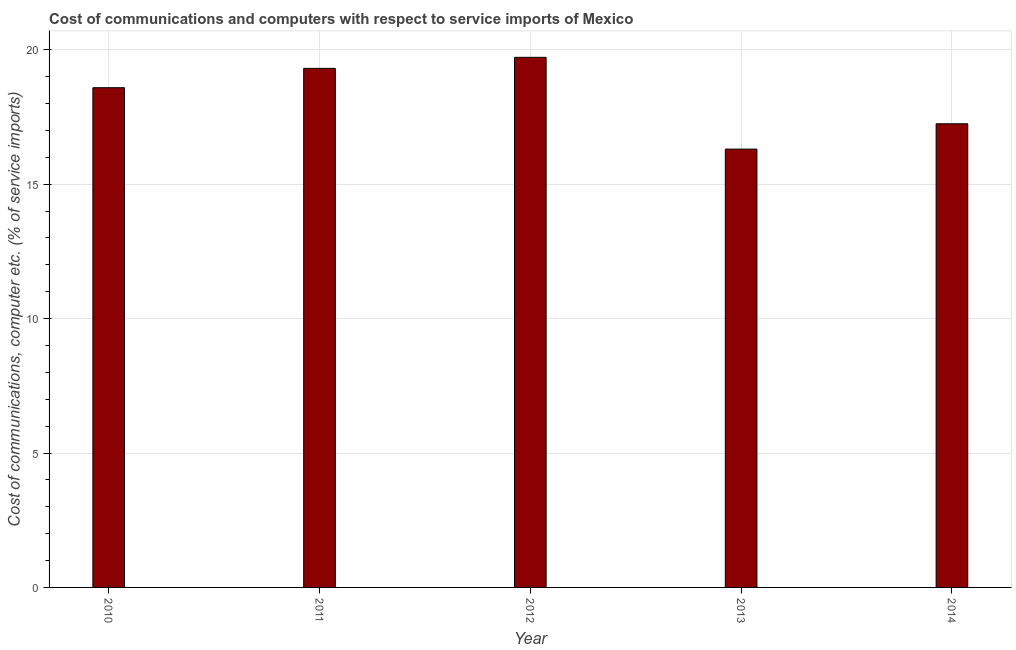Does the graph contain any zero values?
Make the answer very short. No. What is the title of the graph?
Your answer should be compact. Cost of communications and computers with respect to service imports of Mexico. What is the label or title of the Y-axis?
Offer a very short reply. Cost of communications, computer etc. (% of service imports). What is the cost of communications and computer in 2010?
Your answer should be compact. 18.59. Across all years, what is the maximum cost of communications and computer?
Offer a terse response. 19.72. Across all years, what is the minimum cost of communications and computer?
Offer a very short reply. 16.31. In which year was the cost of communications and computer maximum?
Your response must be concise. 2012. In which year was the cost of communications and computer minimum?
Provide a succinct answer. 2013. What is the sum of the cost of communications and computer?
Offer a very short reply. 91.17. What is the difference between the cost of communications and computer in 2010 and 2013?
Offer a very short reply. 2.28. What is the average cost of communications and computer per year?
Give a very brief answer. 18.23. What is the median cost of communications and computer?
Your answer should be very brief. 18.59. In how many years, is the cost of communications and computer greater than 18 %?
Give a very brief answer. 3. What is the ratio of the cost of communications and computer in 2012 to that in 2013?
Ensure brevity in your answer.  1.21. Is the difference between the cost of communications and computer in 2010 and 2011 greater than the difference between any two years?
Give a very brief answer. No. What is the difference between the highest and the second highest cost of communications and computer?
Your answer should be compact. 0.41. What is the difference between the highest and the lowest cost of communications and computer?
Offer a terse response. 3.41. In how many years, is the cost of communications and computer greater than the average cost of communications and computer taken over all years?
Make the answer very short. 3. How many bars are there?
Your answer should be very brief. 5. Are all the bars in the graph horizontal?
Offer a terse response. No. What is the difference between two consecutive major ticks on the Y-axis?
Provide a short and direct response. 5. What is the Cost of communications, computer etc. (% of service imports) in 2010?
Keep it short and to the point. 18.59. What is the Cost of communications, computer etc. (% of service imports) of 2011?
Give a very brief answer. 19.31. What is the Cost of communications, computer etc. (% of service imports) in 2012?
Your answer should be very brief. 19.72. What is the Cost of communications, computer etc. (% of service imports) in 2013?
Provide a succinct answer. 16.31. What is the Cost of communications, computer etc. (% of service imports) in 2014?
Provide a short and direct response. 17.25. What is the difference between the Cost of communications, computer etc. (% of service imports) in 2010 and 2011?
Keep it short and to the point. -0.72. What is the difference between the Cost of communications, computer etc. (% of service imports) in 2010 and 2012?
Offer a terse response. -1.13. What is the difference between the Cost of communications, computer etc. (% of service imports) in 2010 and 2013?
Provide a succinct answer. 2.28. What is the difference between the Cost of communications, computer etc. (% of service imports) in 2010 and 2014?
Provide a succinct answer. 1.34. What is the difference between the Cost of communications, computer etc. (% of service imports) in 2011 and 2012?
Give a very brief answer. -0.41. What is the difference between the Cost of communications, computer etc. (% of service imports) in 2011 and 2013?
Offer a very short reply. 3. What is the difference between the Cost of communications, computer etc. (% of service imports) in 2011 and 2014?
Ensure brevity in your answer.  2.06. What is the difference between the Cost of communications, computer etc. (% of service imports) in 2012 and 2013?
Give a very brief answer. 3.41. What is the difference between the Cost of communications, computer etc. (% of service imports) in 2012 and 2014?
Your answer should be compact. 2.47. What is the difference between the Cost of communications, computer etc. (% of service imports) in 2013 and 2014?
Make the answer very short. -0.94. What is the ratio of the Cost of communications, computer etc. (% of service imports) in 2010 to that in 2011?
Ensure brevity in your answer.  0.96. What is the ratio of the Cost of communications, computer etc. (% of service imports) in 2010 to that in 2012?
Provide a succinct answer. 0.94. What is the ratio of the Cost of communications, computer etc. (% of service imports) in 2010 to that in 2013?
Make the answer very short. 1.14. What is the ratio of the Cost of communications, computer etc. (% of service imports) in 2010 to that in 2014?
Ensure brevity in your answer.  1.08. What is the ratio of the Cost of communications, computer etc. (% of service imports) in 2011 to that in 2013?
Your answer should be very brief. 1.18. What is the ratio of the Cost of communications, computer etc. (% of service imports) in 2011 to that in 2014?
Keep it short and to the point. 1.12. What is the ratio of the Cost of communications, computer etc. (% of service imports) in 2012 to that in 2013?
Give a very brief answer. 1.21. What is the ratio of the Cost of communications, computer etc. (% of service imports) in 2012 to that in 2014?
Provide a short and direct response. 1.14. What is the ratio of the Cost of communications, computer etc. (% of service imports) in 2013 to that in 2014?
Provide a succinct answer. 0.94. 